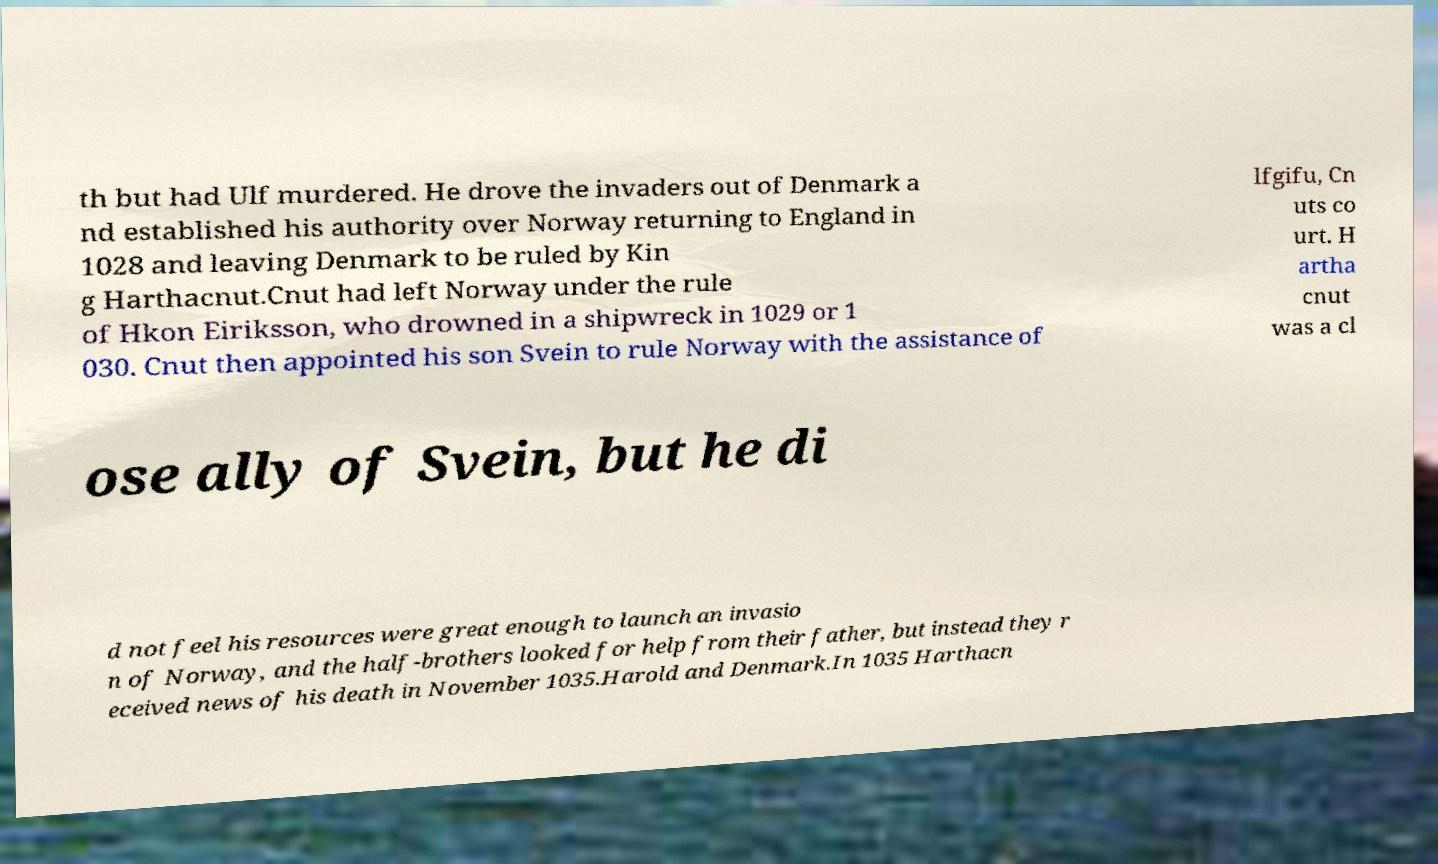Could you assist in decoding the text presented in this image and type it out clearly? th but had Ulf murdered. He drove the invaders out of Denmark a nd established his authority over Norway returning to England in 1028 and leaving Denmark to be ruled by Kin g Harthacnut.Cnut had left Norway under the rule of Hkon Eiriksson, who drowned in a shipwreck in 1029 or 1 030. Cnut then appointed his son Svein to rule Norway with the assistance of lfgifu, Cn uts co urt. H artha cnut was a cl ose ally of Svein, but he di d not feel his resources were great enough to launch an invasio n of Norway, and the half-brothers looked for help from their father, but instead they r eceived news of his death in November 1035.Harold and Denmark.In 1035 Harthacn 